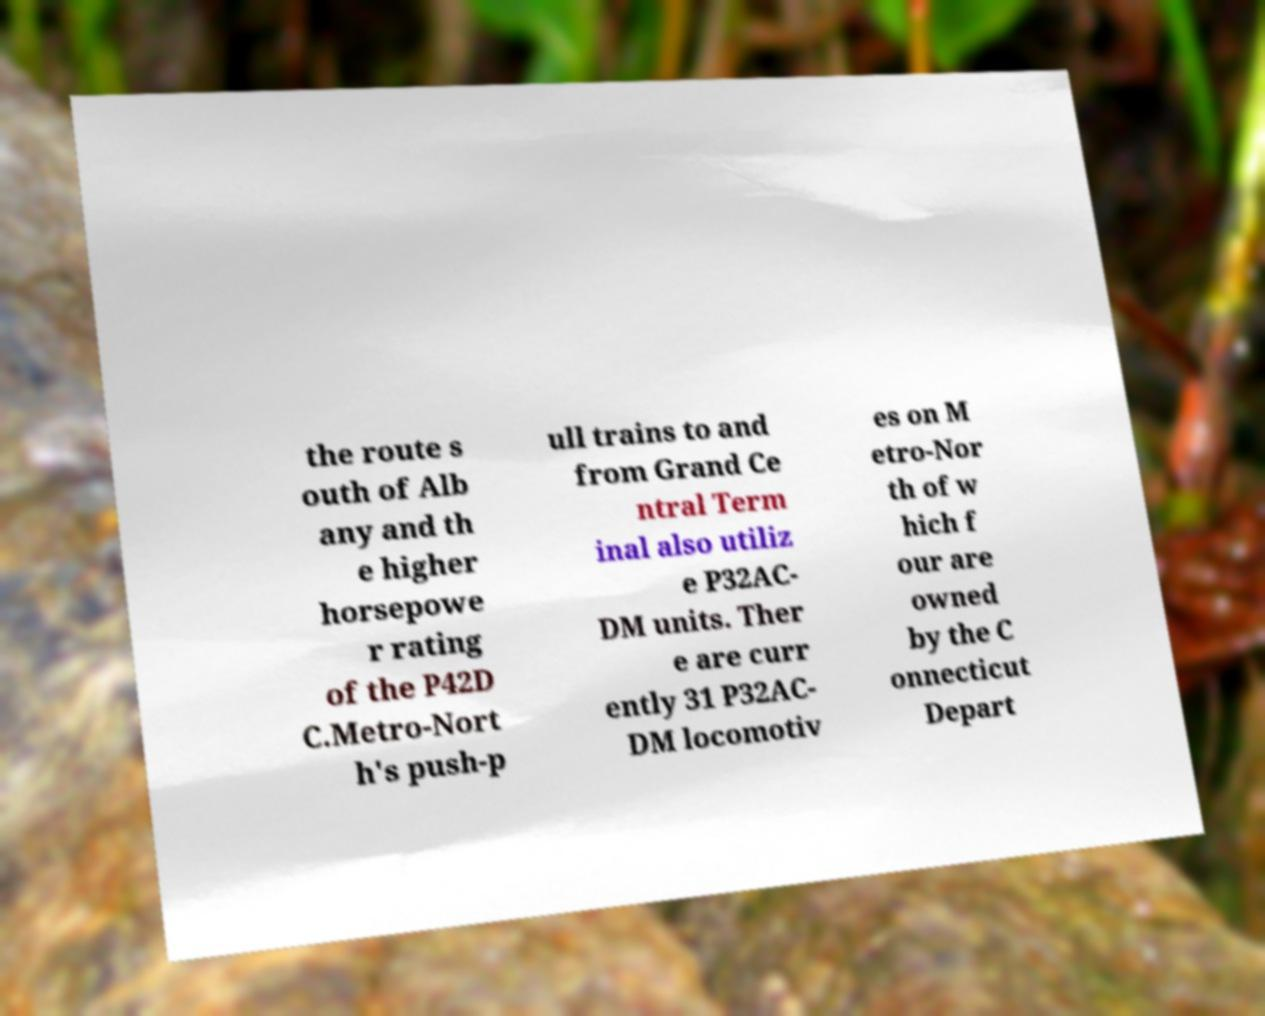There's text embedded in this image that I need extracted. Can you transcribe it verbatim? the route s outh of Alb any and th e higher horsepowe r rating of the P42D C.Metro-Nort h's push-p ull trains to and from Grand Ce ntral Term inal also utiliz e P32AC- DM units. Ther e are curr ently 31 P32AC- DM locomotiv es on M etro-Nor th of w hich f our are owned by the C onnecticut Depart 